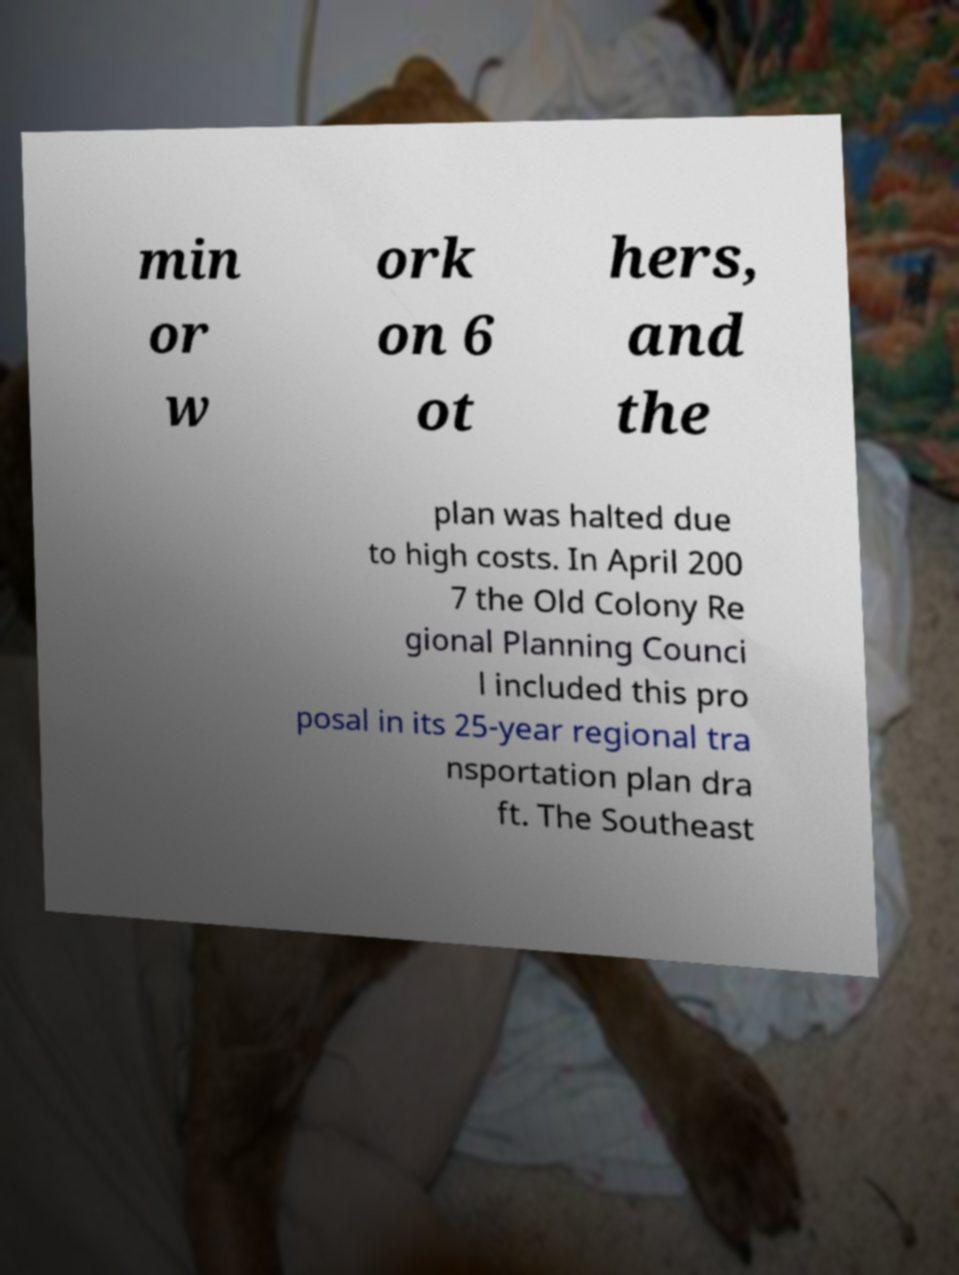I need the written content from this picture converted into text. Can you do that? min or w ork on 6 ot hers, and the plan was halted due to high costs. In April 200 7 the Old Colony Re gional Planning Counci l included this pro posal in its 25-year regional tra nsportation plan dra ft. The Southeast 